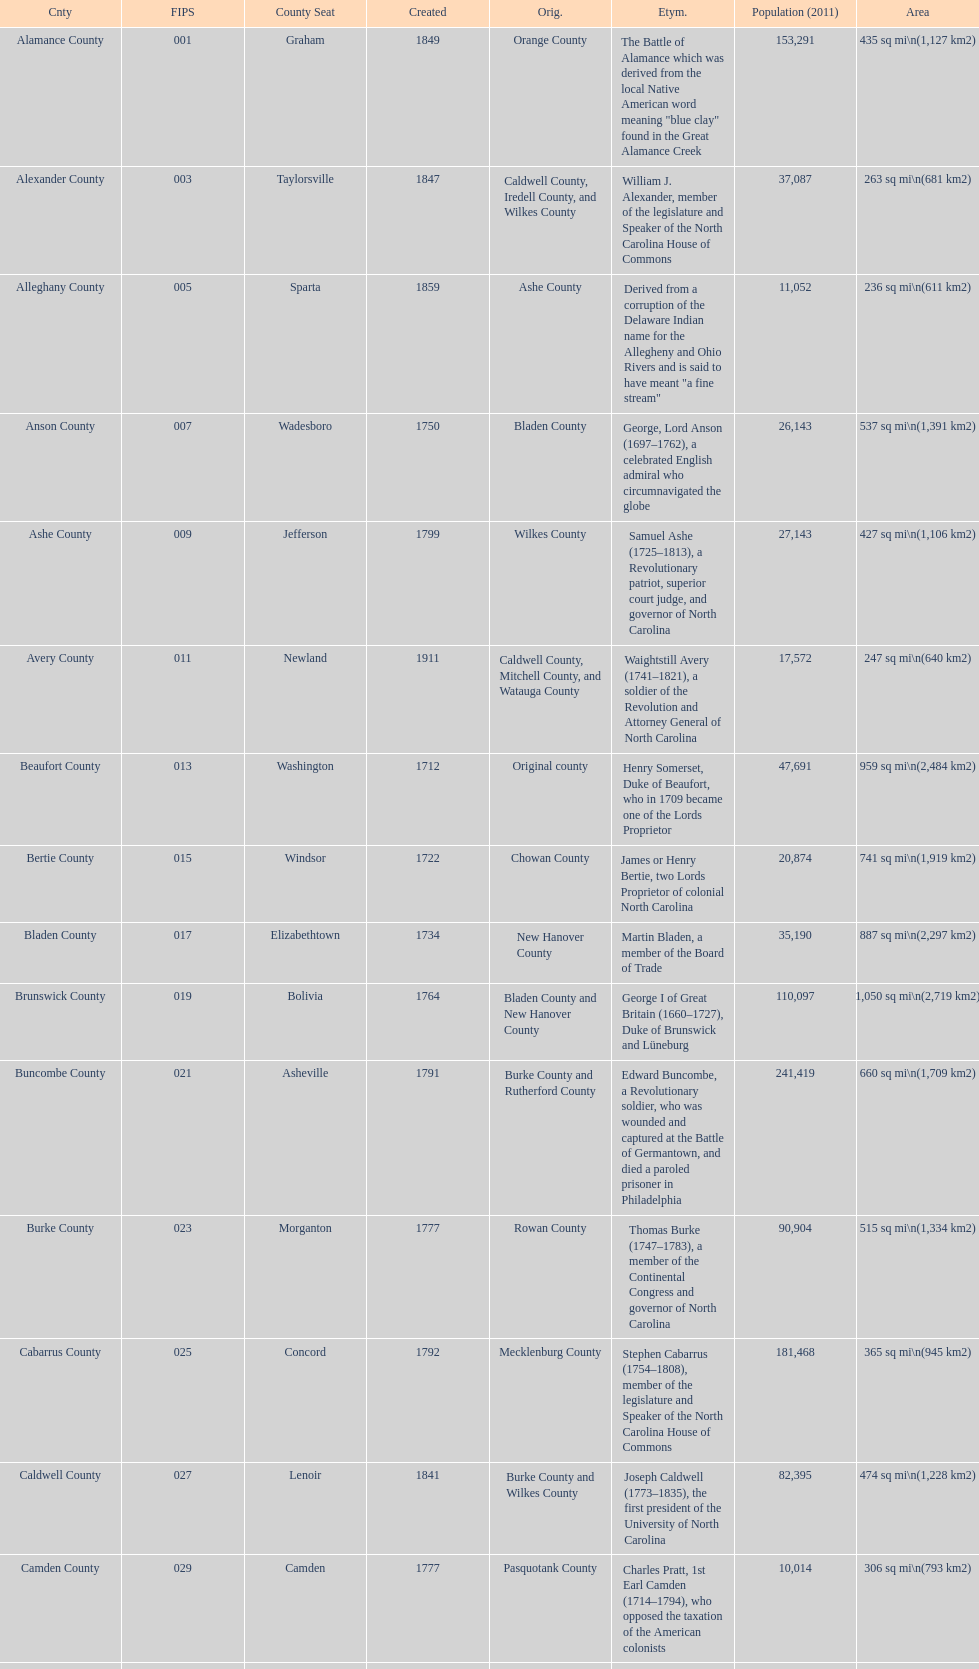Other than mecklenburg which county has the largest population? Wake County. 